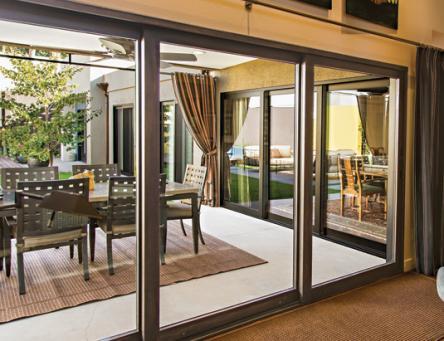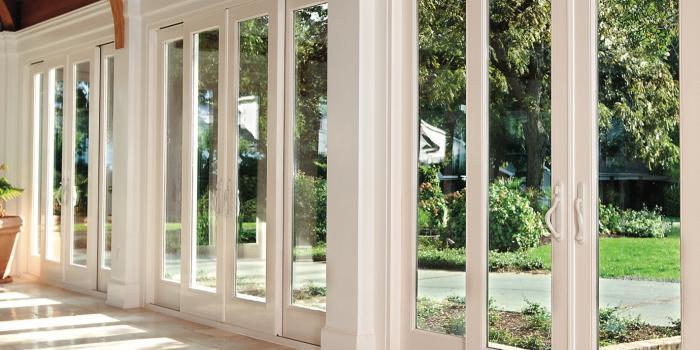The first image is the image on the left, the second image is the image on the right. Considering the images on both sides, is "All the doors are closed." valid? Answer yes or no. Yes. The first image is the image on the left, the second image is the image on the right. For the images displayed, is the sentence "There is at least one chair visible through the sliding glass doors." factually correct? Answer yes or no. Yes. 